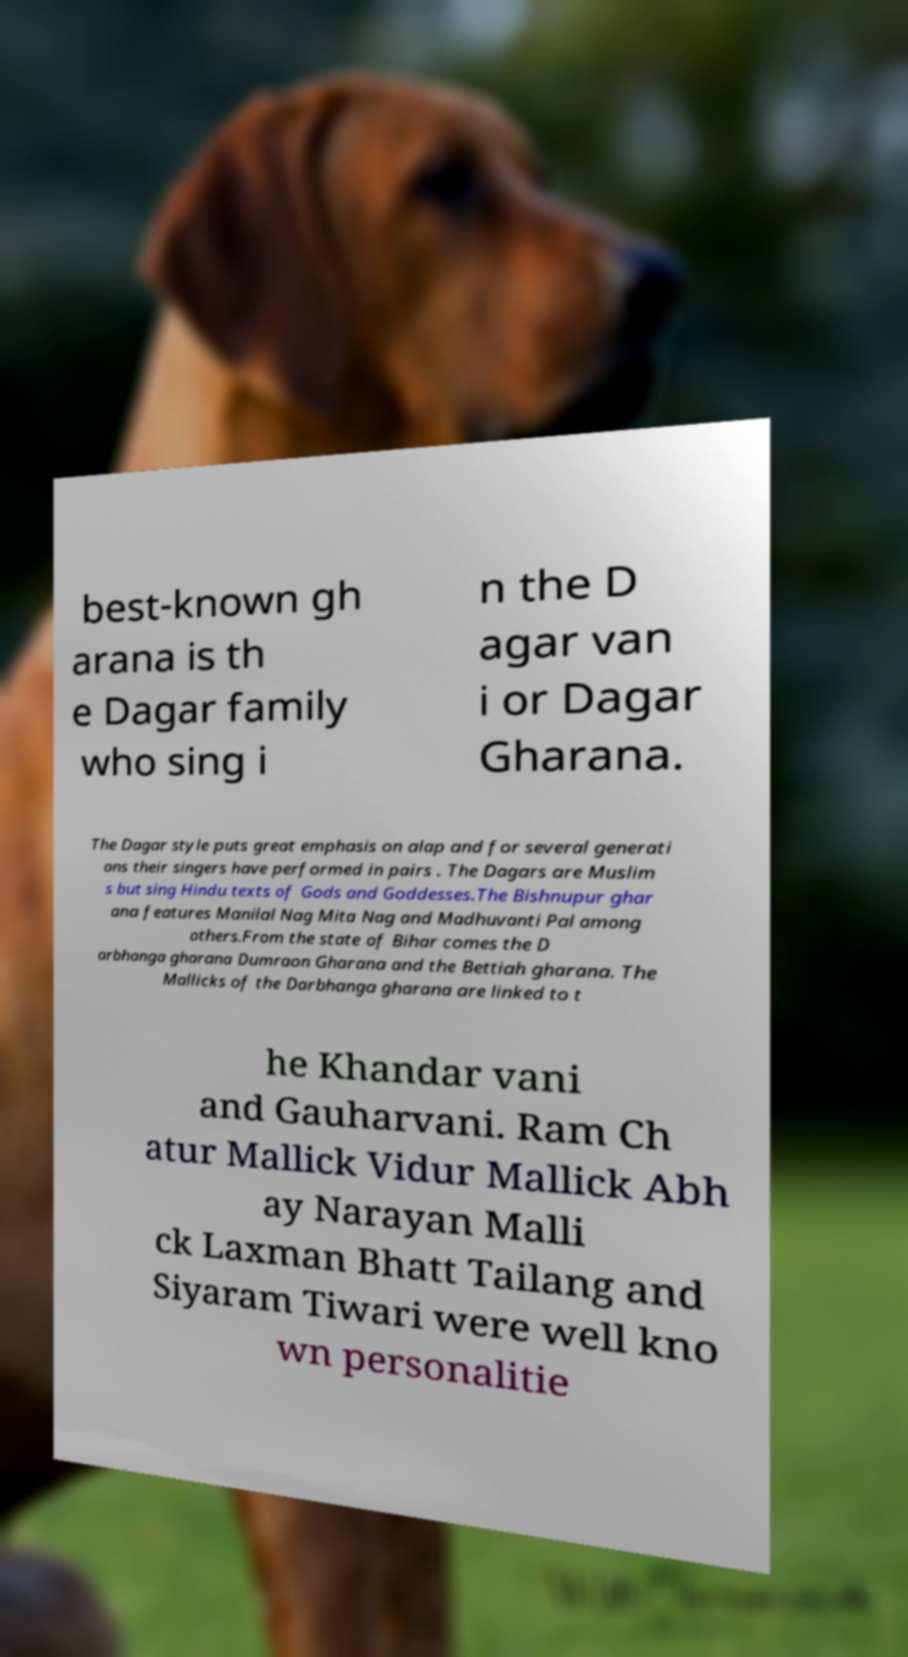Please identify and transcribe the text found in this image. best-known gh arana is th e Dagar family who sing i n the D agar van i or Dagar Gharana. The Dagar style puts great emphasis on alap and for several generati ons their singers have performed in pairs . The Dagars are Muslim s but sing Hindu texts of Gods and Goddesses.The Bishnupur ghar ana features Manilal Nag Mita Nag and Madhuvanti Pal among others.From the state of Bihar comes the D arbhanga gharana Dumraon Gharana and the Bettiah gharana. The Mallicks of the Darbhanga gharana are linked to t he Khandar vani and Gauharvani. Ram Ch atur Mallick Vidur Mallick Abh ay Narayan Malli ck Laxman Bhatt Tailang and Siyaram Tiwari were well kno wn personalitie 